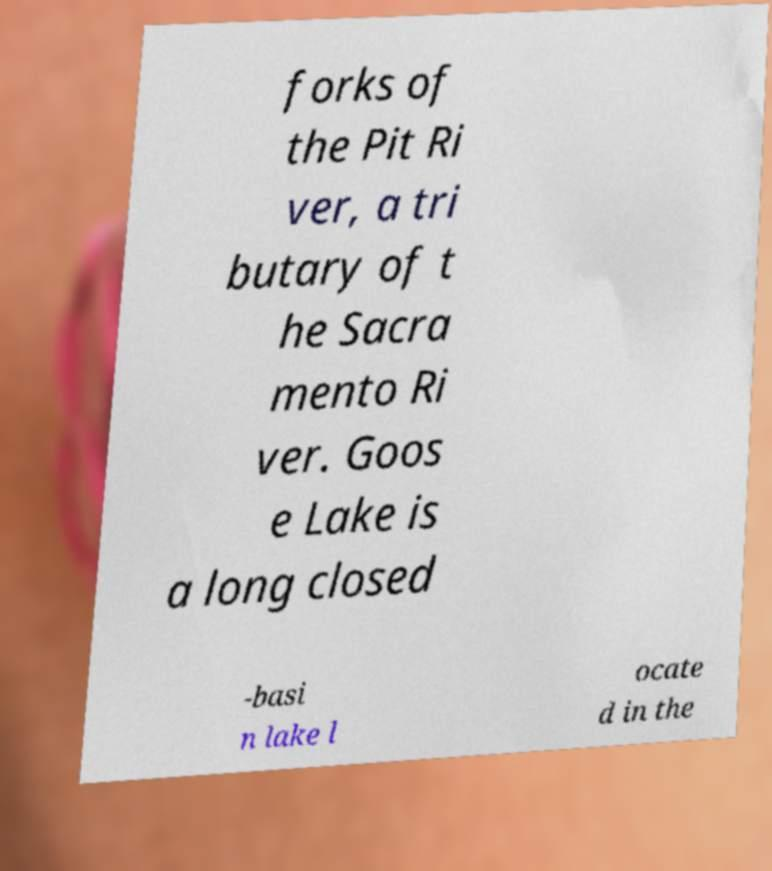Please identify and transcribe the text found in this image. forks of the Pit Ri ver, a tri butary of t he Sacra mento Ri ver. Goos e Lake is a long closed -basi n lake l ocate d in the 